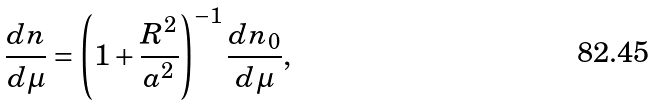Convert formula to latex. <formula><loc_0><loc_0><loc_500><loc_500>\frac { d n } { d \mu } = \left ( 1 + \frac { R ^ { 2 } } { a ^ { 2 } } \right ) ^ { - 1 } \frac { d n _ { 0 } } { d \mu } ,</formula> 